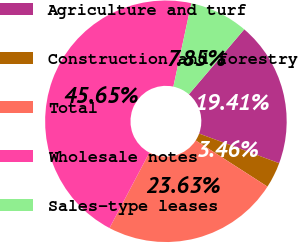Convert chart to OTSL. <chart><loc_0><loc_0><loc_500><loc_500><pie_chart><fcel>Agriculture and turf<fcel>Construction and forestry<fcel>Total<fcel>Wholesale notes<fcel>Sales-type leases<nl><fcel>19.41%<fcel>3.46%<fcel>23.63%<fcel>45.65%<fcel>7.85%<nl></chart> 